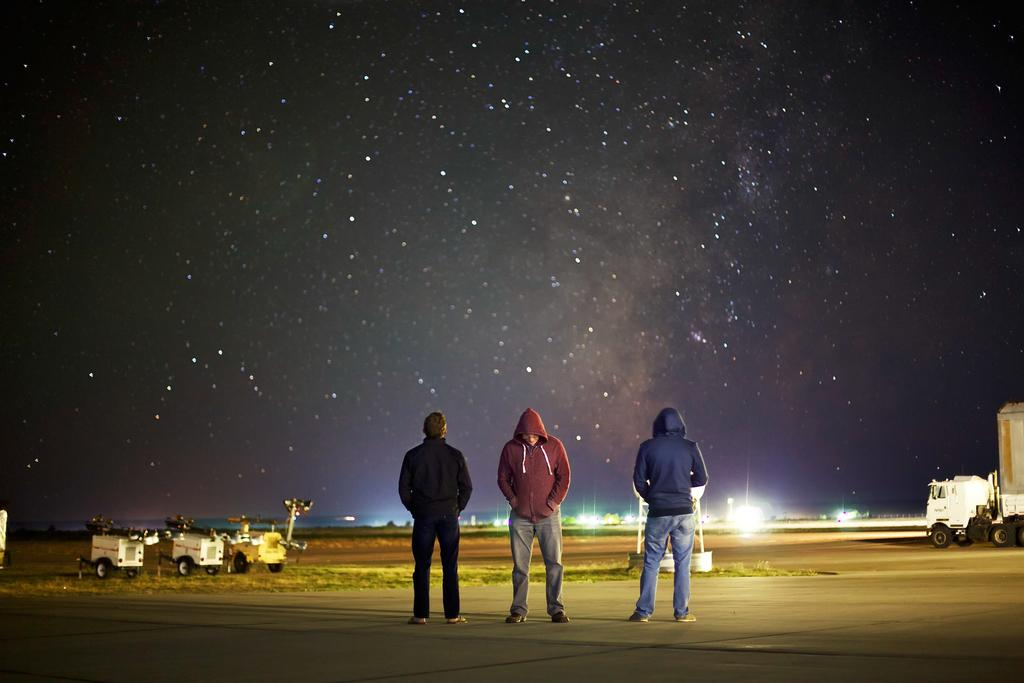What are the people in the image doing? The people in the image are standing on the road in the center. What can be seen in the background of the image? There is sky visible in the background of the image. What else is present in the image besides people? There are vehicles and grass in the image. Can you see any cherries growing on the grass in the image? There are no cherries visible in the image; it only shows people standing on the road, vehicles, and grass. 